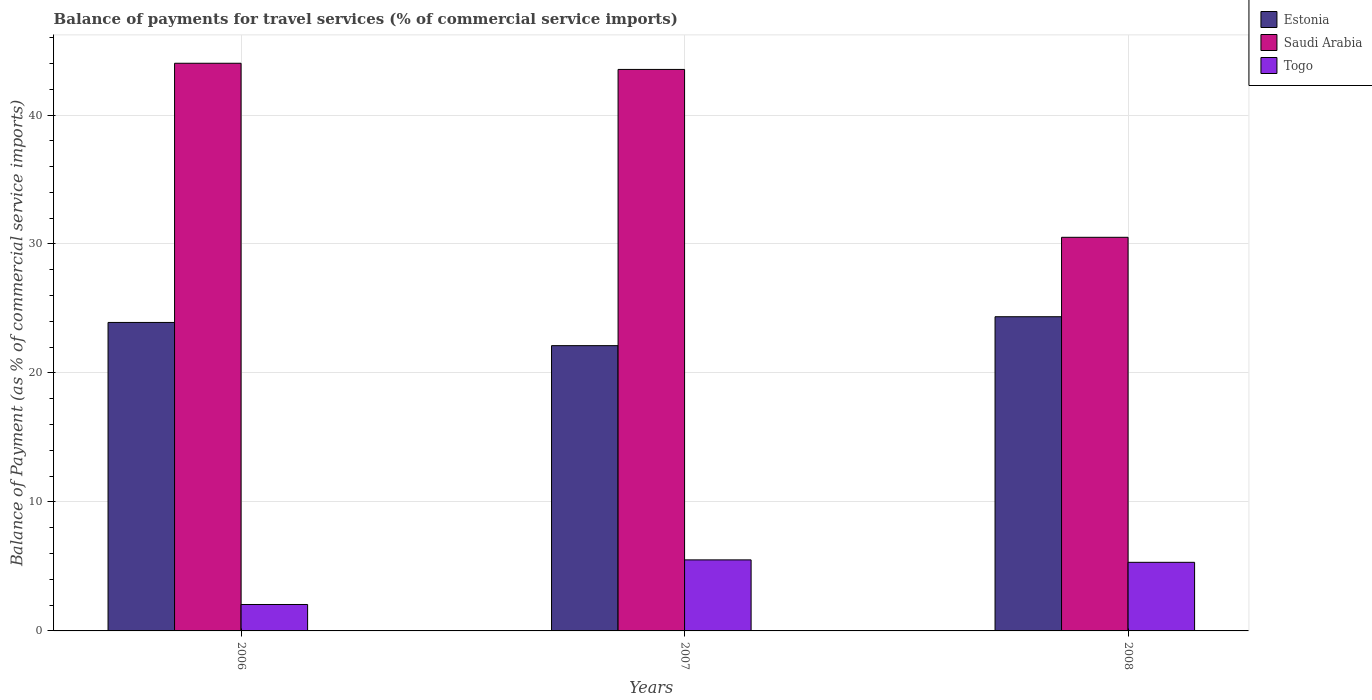How many groups of bars are there?
Your response must be concise. 3. Are the number of bars per tick equal to the number of legend labels?
Keep it short and to the point. Yes. What is the label of the 3rd group of bars from the left?
Provide a succinct answer. 2008. In how many cases, is the number of bars for a given year not equal to the number of legend labels?
Keep it short and to the point. 0. What is the balance of payments for travel services in Togo in 2006?
Your response must be concise. 2.05. Across all years, what is the maximum balance of payments for travel services in Saudi Arabia?
Your response must be concise. 44.01. Across all years, what is the minimum balance of payments for travel services in Saudi Arabia?
Your answer should be very brief. 30.52. In which year was the balance of payments for travel services in Estonia minimum?
Keep it short and to the point. 2007. What is the total balance of payments for travel services in Estonia in the graph?
Your answer should be compact. 70.4. What is the difference between the balance of payments for travel services in Togo in 2007 and that in 2008?
Your answer should be very brief. 0.19. What is the difference between the balance of payments for travel services in Saudi Arabia in 2008 and the balance of payments for travel services in Estonia in 2007?
Ensure brevity in your answer.  8.4. What is the average balance of payments for travel services in Estonia per year?
Give a very brief answer. 23.47. In the year 2008, what is the difference between the balance of payments for travel services in Togo and balance of payments for travel services in Estonia?
Your response must be concise. -19.04. In how many years, is the balance of payments for travel services in Estonia greater than 18 %?
Make the answer very short. 3. What is the ratio of the balance of payments for travel services in Estonia in 2007 to that in 2008?
Your answer should be compact. 0.91. Is the balance of payments for travel services in Estonia in 2006 less than that in 2008?
Your answer should be very brief. Yes. What is the difference between the highest and the second highest balance of payments for travel services in Togo?
Offer a very short reply. 0.19. What is the difference between the highest and the lowest balance of payments for travel services in Estonia?
Provide a succinct answer. 2.24. In how many years, is the balance of payments for travel services in Togo greater than the average balance of payments for travel services in Togo taken over all years?
Provide a succinct answer. 2. Is the sum of the balance of payments for travel services in Saudi Arabia in 2006 and 2008 greater than the maximum balance of payments for travel services in Estonia across all years?
Offer a very short reply. Yes. What does the 2nd bar from the left in 2006 represents?
Ensure brevity in your answer.  Saudi Arabia. What does the 1st bar from the right in 2006 represents?
Your answer should be compact. Togo. How many bars are there?
Provide a succinct answer. 9. Are all the bars in the graph horizontal?
Provide a succinct answer. No. How many years are there in the graph?
Your response must be concise. 3. What is the difference between two consecutive major ticks on the Y-axis?
Keep it short and to the point. 10. Are the values on the major ticks of Y-axis written in scientific E-notation?
Your response must be concise. No. Does the graph contain grids?
Make the answer very short. Yes. Where does the legend appear in the graph?
Offer a very short reply. Top right. How many legend labels are there?
Keep it short and to the point. 3. What is the title of the graph?
Your answer should be very brief. Balance of payments for travel services (% of commercial service imports). What is the label or title of the Y-axis?
Your response must be concise. Balance of Payment (as % of commercial service imports). What is the Balance of Payment (as % of commercial service imports) in Estonia in 2006?
Offer a terse response. 23.92. What is the Balance of Payment (as % of commercial service imports) of Saudi Arabia in 2006?
Offer a very short reply. 44.01. What is the Balance of Payment (as % of commercial service imports) of Togo in 2006?
Provide a succinct answer. 2.05. What is the Balance of Payment (as % of commercial service imports) in Estonia in 2007?
Your response must be concise. 22.12. What is the Balance of Payment (as % of commercial service imports) of Saudi Arabia in 2007?
Your response must be concise. 43.53. What is the Balance of Payment (as % of commercial service imports) in Togo in 2007?
Your answer should be compact. 5.51. What is the Balance of Payment (as % of commercial service imports) of Estonia in 2008?
Provide a succinct answer. 24.36. What is the Balance of Payment (as % of commercial service imports) in Saudi Arabia in 2008?
Provide a succinct answer. 30.52. What is the Balance of Payment (as % of commercial service imports) of Togo in 2008?
Provide a succinct answer. 5.32. Across all years, what is the maximum Balance of Payment (as % of commercial service imports) in Estonia?
Make the answer very short. 24.36. Across all years, what is the maximum Balance of Payment (as % of commercial service imports) of Saudi Arabia?
Your answer should be compact. 44.01. Across all years, what is the maximum Balance of Payment (as % of commercial service imports) in Togo?
Offer a very short reply. 5.51. Across all years, what is the minimum Balance of Payment (as % of commercial service imports) of Estonia?
Your answer should be compact. 22.12. Across all years, what is the minimum Balance of Payment (as % of commercial service imports) in Saudi Arabia?
Offer a very short reply. 30.52. Across all years, what is the minimum Balance of Payment (as % of commercial service imports) of Togo?
Your answer should be compact. 2.05. What is the total Balance of Payment (as % of commercial service imports) of Estonia in the graph?
Offer a very short reply. 70.4. What is the total Balance of Payment (as % of commercial service imports) of Saudi Arabia in the graph?
Provide a succinct answer. 118.07. What is the total Balance of Payment (as % of commercial service imports) of Togo in the graph?
Your response must be concise. 12.88. What is the difference between the Balance of Payment (as % of commercial service imports) in Estonia in 2006 and that in 2007?
Ensure brevity in your answer.  1.8. What is the difference between the Balance of Payment (as % of commercial service imports) of Saudi Arabia in 2006 and that in 2007?
Your answer should be compact. 0.48. What is the difference between the Balance of Payment (as % of commercial service imports) of Togo in 2006 and that in 2007?
Your answer should be very brief. -3.46. What is the difference between the Balance of Payment (as % of commercial service imports) in Estonia in 2006 and that in 2008?
Your answer should be compact. -0.44. What is the difference between the Balance of Payment (as % of commercial service imports) of Saudi Arabia in 2006 and that in 2008?
Offer a very short reply. 13.49. What is the difference between the Balance of Payment (as % of commercial service imports) of Togo in 2006 and that in 2008?
Ensure brevity in your answer.  -3.27. What is the difference between the Balance of Payment (as % of commercial service imports) in Estonia in 2007 and that in 2008?
Give a very brief answer. -2.24. What is the difference between the Balance of Payment (as % of commercial service imports) of Saudi Arabia in 2007 and that in 2008?
Your answer should be compact. 13.02. What is the difference between the Balance of Payment (as % of commercial service imports) in Togo in 2007 and that in 2008?
Provide a succinct answer. 0.19. What is the difference between the Balance of Payment (as % of commercial service imports) of Estonia in 2006 and the Balance of Payment (as % of commercial service imports) of Saudi Arabia in 2007?
Your answer should be very brief. -19.62. What is the difference between the Balance of Payment (as % of commercial service imports) of Estonia in 2006 and the Balance of Payment (as % of commercial service imports) of Togo in 2007?
Provide a succinct answer. 18.41. What is the difference between the Balance of Payment (as % of commercial service imports) in Saudi Arabia in 2006 and the Balance of Payment (as % of commercial service imports) in Togo in 2007?
Your answer should be very brief. 38.51. What is the difference between the Balance of Payment (as % of commercial service imports) of Estonia in 2006 and the Balance of Payment (as % of commercial service imports) of Saudi Arabia in 2008?
Your response must be concise. -6.6. What is the difference between the Balance of Payment (as % of commercial service imports) of Estonia in 2006 and the Balance of Payment (as % of commercial service imports) of Togo in 2008?
Give a very brief answer. 18.6. What is the difference between the Balance of Payment (as % of commercial service imports) in Saudi Arabia in 2006 and the Balance of Payment (as % of commercial service imports) in Togo in 2008?
Offer a terse response. 38.69. What is the difference between the Balance of Payment (as % of commercial service imports) in Estonia in 2007 and the Balance of Payment (as % of commercial service imports) in Saudi Arabia in 2008?
Your answer should be very brief. -8.4. What is the difference between the Balance of Payment (as % of commercial service imports) of Estonia in 2007 and the Balance of Payment (as % of commercial service imports) of Togo in 2008?
Give a very brief answer. 16.8. What is the difference between the Balance of Payment (as % of commercial service imports) of Saudi Arabia in 2007 and the Balance of Payment (as % of commercial service imports) of Togo in 2008?
Offer a very short reply. 38.22. What is the average Balance of Payment (as % of commercial service imports) of Estonia per year?
Your answer should be very brief. 23.47. What is the average Balance of Payment (as % of commercial service imports) of Saudi Arabia per year?
Make the answer very short. 39.36. What is the average Balance of Payment (as % of commercial service imports) in Togo per year?
Ensure brevity in your answer.  4.29. In the year 2006, what is the difference between the Balance of Payment (as % of commercial service imports) of Estonia and Balance of Payment (as % of commercial service imports) of Saudi Arabia?
Keep it short and to the point. -20.1. In the year 2006, what is the difference between the Balance of Payment (as % of commercial service imports) of Estonia and Balance of Payment (as % of commercial service imports) of Togo?
Make the answer very short. 21.87. In the year 2006, what is the difference between the Balance of Payment (as % of commercial service imports) in Saudi Arabia and Balance of Payment (as % of commercial service imports) in Togo?
Ensure brevity in your answer.  41.96. In the year 2007, what is the difference between the Balance of Payment (as % of commercial service imports) of Estonia and Balance of Payment (as % of commercial service imports) of Saudi Arabia?
Provide a short and direct response. -21.42. In the year 2007, what is the difference between the Balance of Payment (as % of commercial service imports) of Estonia and Balance of Payment (as % of commercial service imports) of Togo?
Your response must be concise. 16.61. In the year 2007, what is the difference between the Balance of Payment (as % of commercial service imports) in Saudi Arabia and Balance of Payment (as % of commercial service imports) in Togo?
Your answer should be compact. 38.03. In the year 2008, what is the difference between the Balance of Payment (as % of commercial service imports) in Estonia and Balance of Payment (as % of commercial service imports) in Saudi Arabia?
Your response must be concise. -6.16. In the year 2008, what is the difference between the Balance of Payment (as % of commercial service imports) of Estonia and Balance of Payment (as % of commercial service imports) of Togo?
Your answer should be compact. 19.04. In the year 2008, what is the difference between the Balance of Payment (as % of commercial service imports) in Saudi Arabia and Balance of Payment (as % of commercial service imports) in Togo?
Make the answer very short. 25.2. What is the ratio of the Balance of Payment (as % of commercial service imports) in Estonia in 2006 to that in 2007?
Your answer should be very brief. 1.08. What is the ratio of the Balance of Payment (as % of commercial service imports) of Togo in 2006 to that in 2007?
Provide a succinct answer. 0.37. What is the ratio of the Balance of Payment (as % of commercial service imports) of Estonia in 2006 to that in 2008?
Provide a short and direct response. 0.98. What is the ratio of the Balance of Payment (as % of commercial service imports) of Saudi Arabia in 2006 to that in 2008?
Provide a succinct answer. 1.44. What is the ratio of the Balance of Payment (as % of commercial service imports) in Togo in 2006 to that in 2008?
Make the answer very short. 0.39. What is the ratio of the Balance of Payment (as % of commercial service imports) in Estonia in 2007 to that in 2008?
Provide a succinct answer. 0.91. What is the ratio of the Balance of Payment (as % of commercial service imports) in Saudi Arabia in 2007 to that in 2008?
Make the answer very short. 1.43. What is the ratio of the Balance of Payment (as % of commercial service imports) in Togo in 2007 to that in 2008?
Provide a short and direct response. 1.04. What is the difference between the highest and the second highest Balance of Payment (as % of commercial service imports) of Estonia?
Ensure brevity in your answer.  0.44. What is the difference between the highest and the second highest Balance of Payment (as % of commercial service imports) of Saudi Arabia?
Provide a short and direct response. 0.48. What is the difference between the highest and the second highest Balance of Payment (as % of commercial service imports) in Togo?
Ensure brevity in your answer.  0.19. What is the difference between the highest and the lowest Balance of Payment (as % of commercial service imports) in Estonia?
Your response must be concise. 2.24. What is the difference between the highest and the lowest Balance of Payment (as % of commercial service imports) in Saudi Arabia?
Provide a short and direct response. 13.49. What is the difference between the highest and the lowest Balance of Payment (as % of commercial service imports) in Togo?
Your response must be concise. 3.46. 